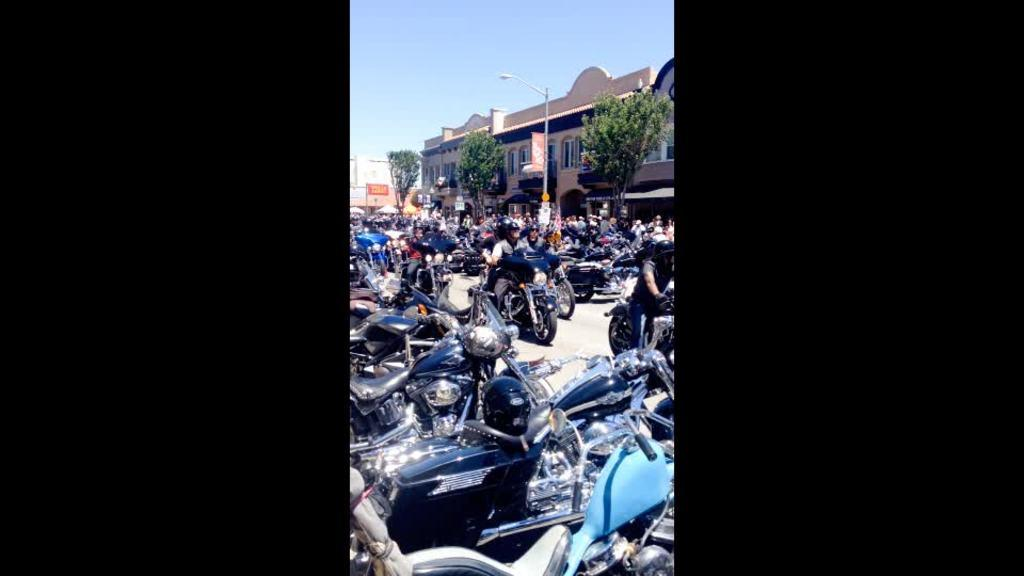What type of vehicles can be seen in the image? There are bikes in the image. What else is present in the image besides bikes? There are people on the road and buildings, trees, and boards in the background of the image. Can you describe the pole visible in the image? There is a pole visible in the image, but its specific characteristics are not mentioned in the provided facts. What type of structures can be seen in the background of the image? There are buildings and boards visible in the background of the image. How does the cannon increase its speed in the image? There is no cannon present in the image, so it cannot be determined how it would increase its speed. 